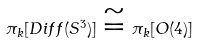Convert formula to latex. <formula><loc_0><loc_0><loc_500><loc_500>\pi _ { k } [ D i f f ( S ^ { 3 } ) ] \cong \pi _ { k } [ O ( 4 ) ]</formula> 